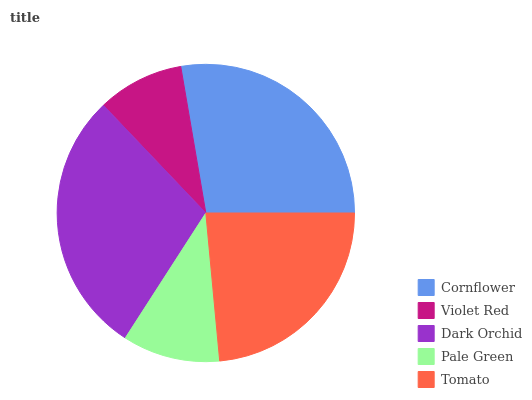Is Violet Red the minimum?
Answer yes or no. Yes. Is Dark Orchid the maximum?
Answer yes or no. Yes. Is Dark Orchid the minimum?
Answer yes or no. No. Is Violet Red the maximum?
Answer yes or no. No. Is Dark Orchid greater than Violet Red?
Answer yes or no. Yes. Is Violet Red less than Dark Orchid?
Answer yes or no. Yes. Is Violet Red greater than Dark Orchid?
Answer yes or no. No. Is Dark Orchid less than Violet Red?
Answer yes or no. No. Is Tomato the high median?
Answer yes or no. Yes. Is Tomato the low median?
Answer yes or no. Yes. Is Dark Orchid the high median?
Answer yes or no. No. Is Cornflower the low median?
Answer yes or no. No. 